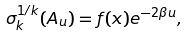Convert formula to latex. <formula><loc_0><loc_0><loc_500><loc_500>\sigma _ { k } ^ { 1 / k } ( A _ { u } ) = f ( x ) e ^ { - 2 \beta u } ,</formula> 